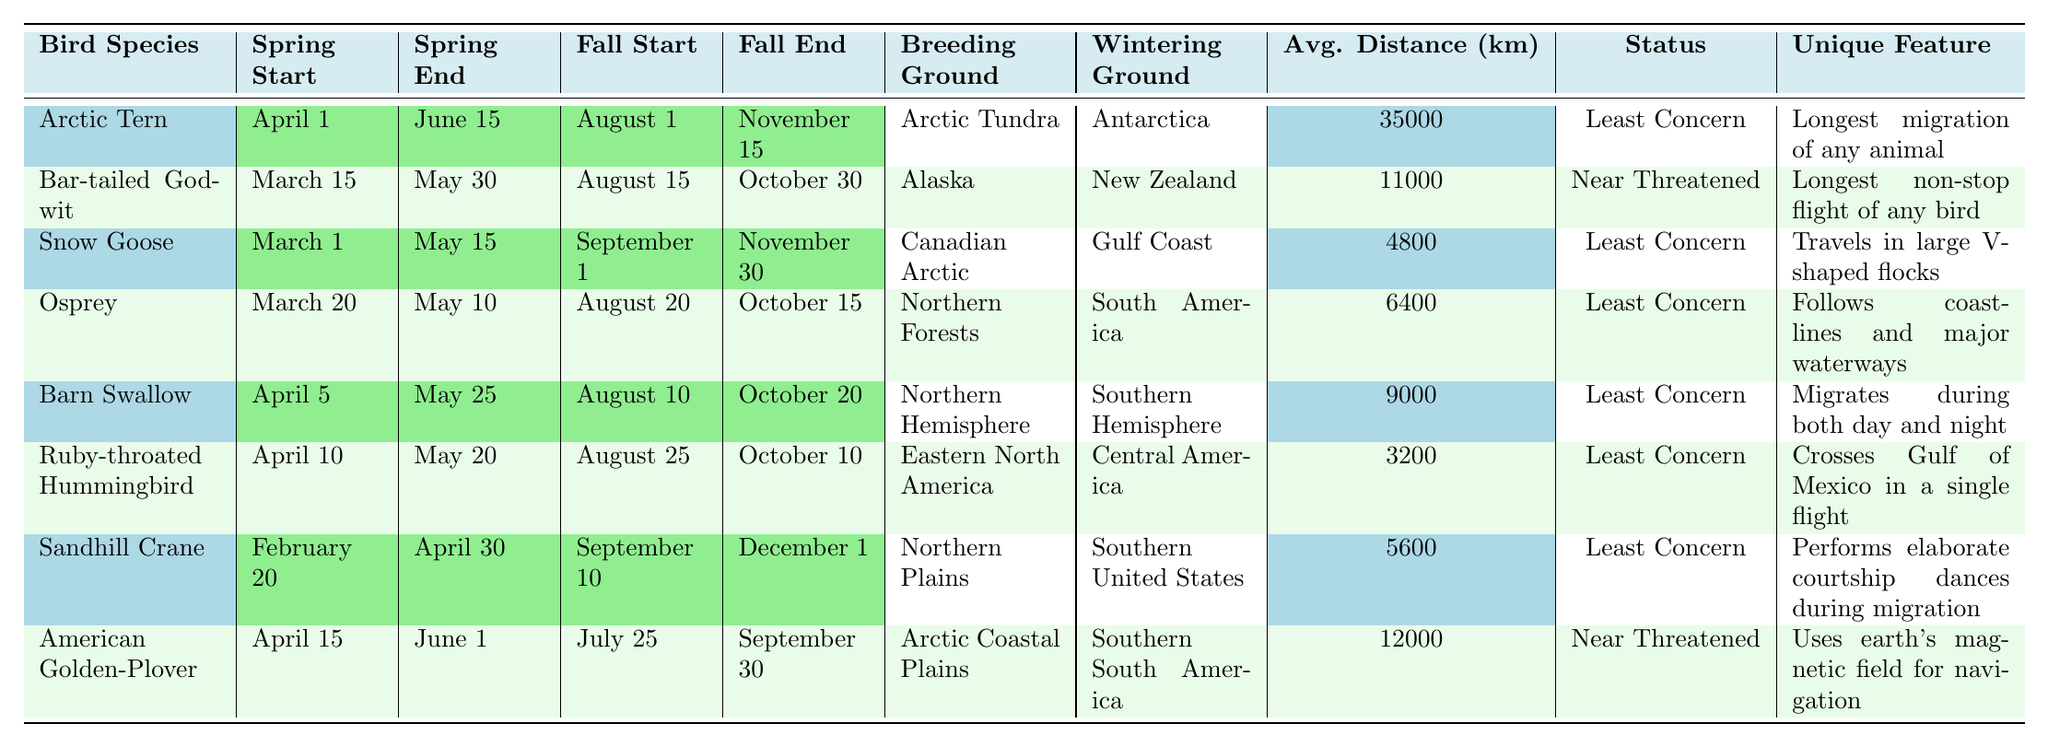What is the average migration distance of the Arctic Tern? The average migration distance for the Arctic Tern, as shown in the table, is listed as 35,000 km.
Answer: 35,000 km Which bird species migrates at the earliest in spring? The earliest spring migration start is for the Snow Goose on March 1, as per the table.
Answer: Snow Goose What is the conservation status of the Bar-tailed Godwit? The table shows that the Bar-tailed Godwit has a conservation status of Near Threatened.
Answer: Near Threatened How long does the Osprey's spring migration last? The spring migration for the Osprey starts on March 20 and ends on May 10, which is a duration of 51 days.
Answer: 51 days Which bird is known for crossing the Gulf of Mexico in a single flight? According to the unique migration features in the table, the Ruby-throated Hummingbird is known for this.
Answer: Ruby-throated Hummingbird Which species has the shortest average migration distance? The bird species with the shortest average migration distance is the Ruby-throated Hummingbird at 3,200 km. This can be found in the average migration distance column of the table.
Answer: Ruby-throated Hummingbird What is the total duration of fall migration for the Snow Goose? The fall migration for the Snow Goose starts on September 1 and ends on November 30, which sums up to 90 days.
Answer: 90 days Is the American Golden-Plover's primary breeding ground in the Southern Hemisphere? No, the American Golden-Plover's primary breeding ground is in the Arctic Coastal Plains, as indicated in the table.
Answer: No How many bird species have a conservation status of Least Concern? In the table, six bird species are noted as having a conservation status of Least Concern. This can be counted from the relevant column in the table.
Answer: 6 Which bird has the longest spring migration duration? The Arctic Tern starts its spring migration on April 1 and ends on June 15, giving it a total duration of 75 days, which is longer than other birds mentioned in the table.
Answer: Arctic Tern 